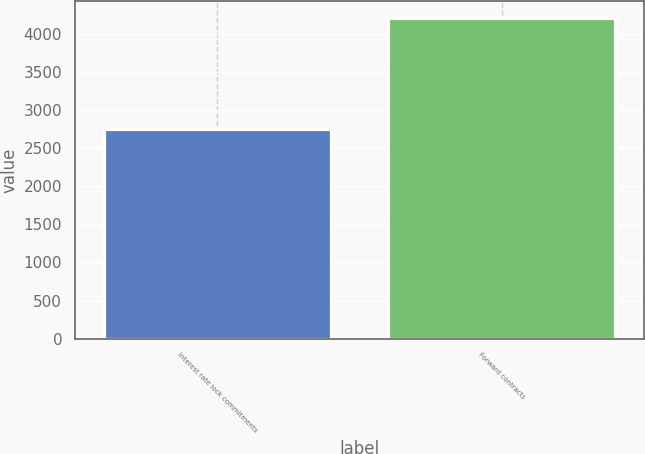Convert chart. <chart><loc_0><loc_0><loc_500><loc_500><bar_chart><fcel>Interest rate lock commitments<fcel>Forward contracts<nl><fcel>2756<fcel>4217<nl></chart> 